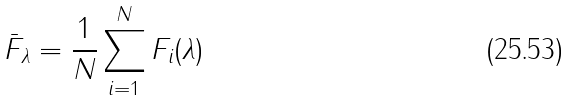<formula> <loc_0><loc_0><loc_500><loc_500>\bar { F } _ { \lambda } = \frac { 1 } { N } \sum _ { i = 1 } ^ { N } F _ { i } ( \lambda )</formula> 